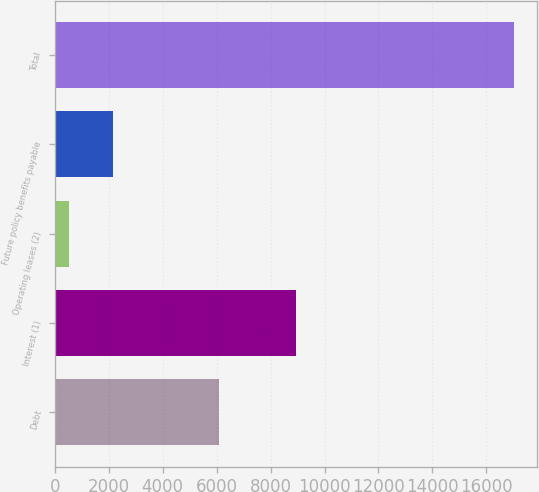Convert chart to OTSL. <chart><loc_0><loc_0><loc_500><loc_500><bar_chart><fcel>Debt<fcel>Interest (1)<fcel>Operating leases (2)<fcel>Future policy benefits payable<fcel>Total<nl><fcel>6097<fcel>8955<fcel>519<fcel>2170.2<fcel>17031<nl></chart> 